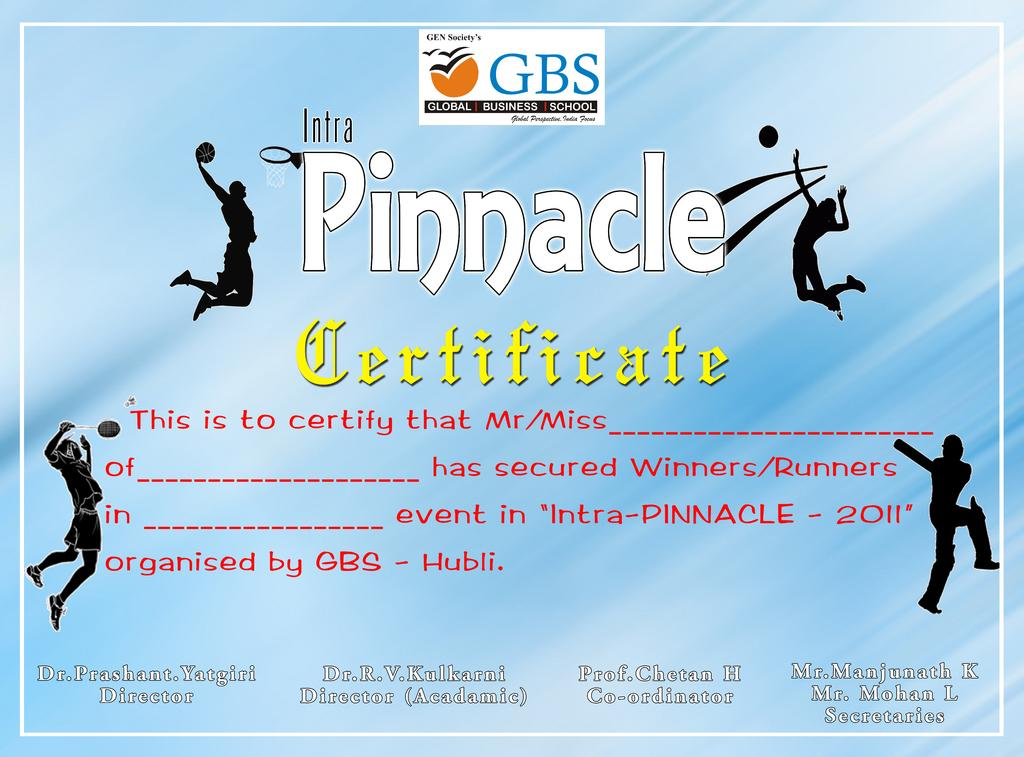<image>
Share a concise interpretation of the image provided. intra pinnacle certificate ad for completing the work 